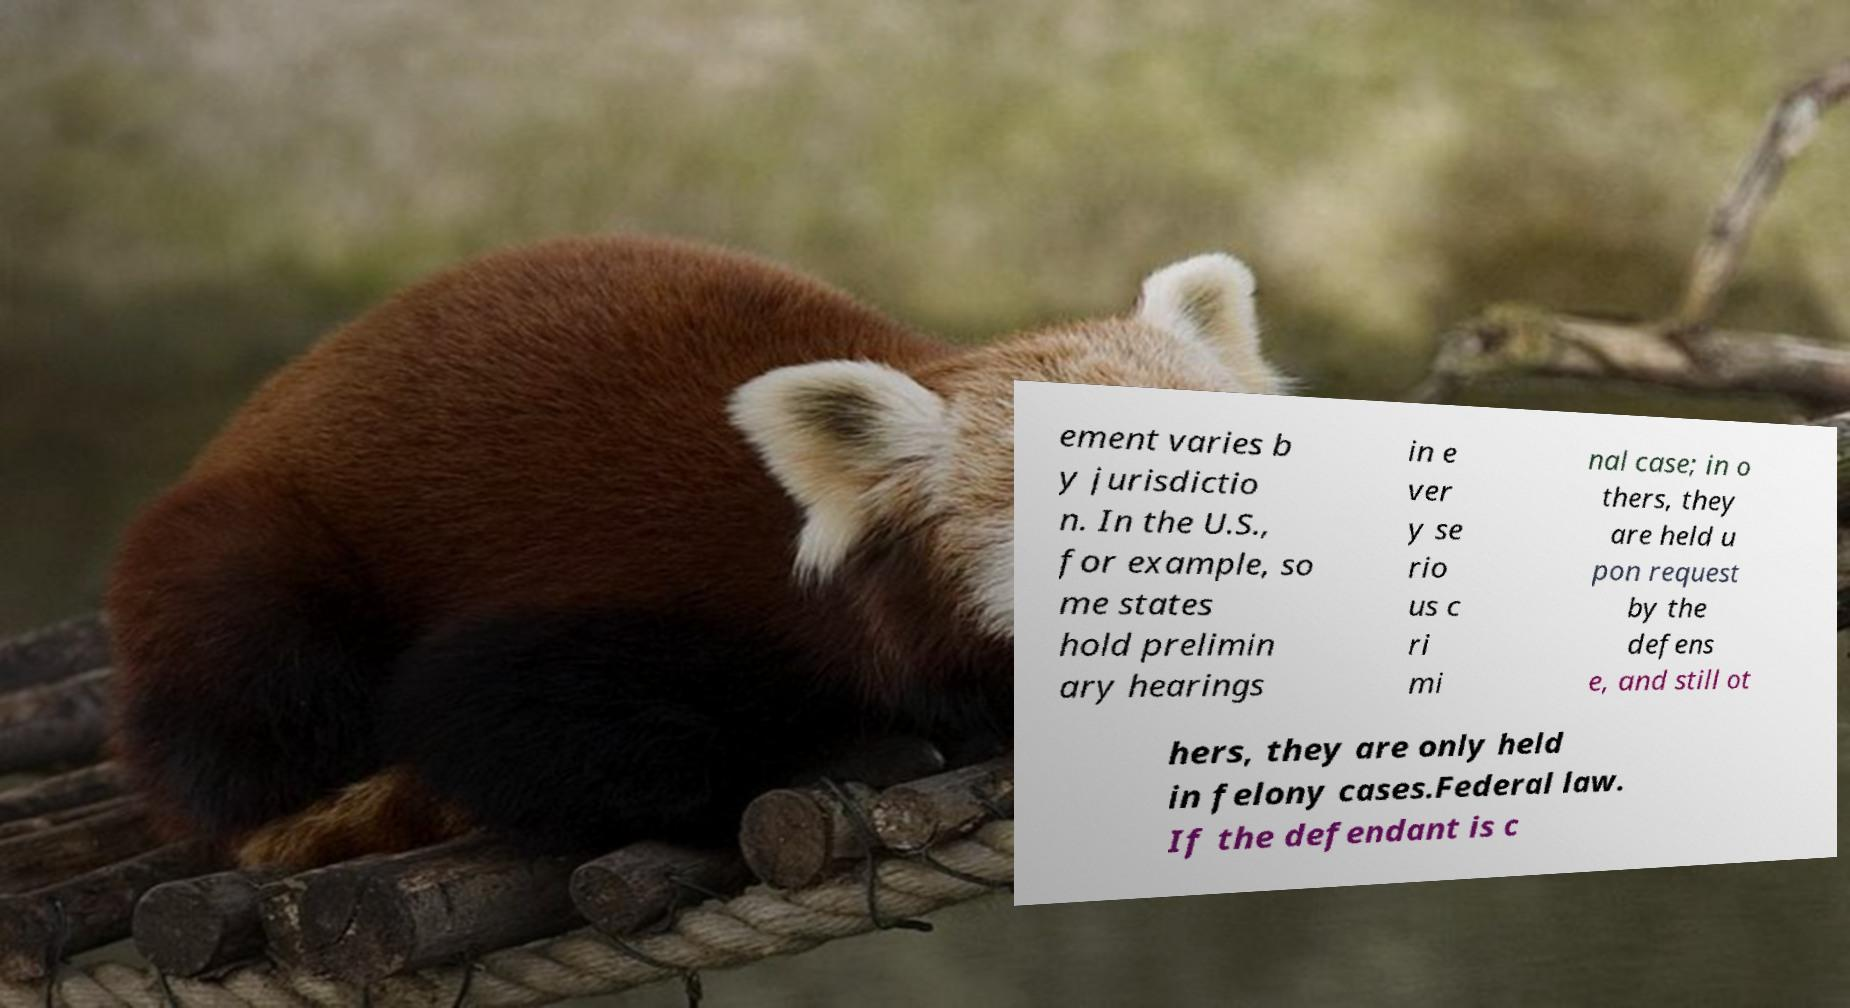Please read and relay the text visible in this image. What does it say? ement varies b y jurisdictio n. In the U.S., for example, so me states hold prelimin ary hearings in e ver y se rio us c ri mi nal case; in o thers, they are held u pon request by the defens e, and still ot hers, they are only held in felony cases.Federal law. If the defendant is c 